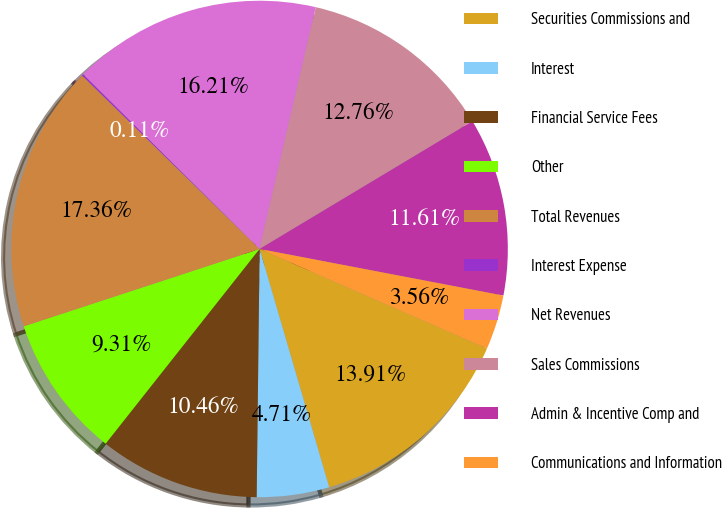Convert chart to OTSL. <chart><loc_0><loc_0><loc_500><loc_500><pie_chart><fcel>Securities Commissions and<fcel>Interest<fcel>Financial Service Fees<fcel>Other<fcel>Total Revenues<fcel>Interest Expense<fcel>Net Revenues<fcel>Sales Commissions<fcel>Admin & Incentive Comp and<fcel>Communications and Information<nl><fcel>13.91%<fcel>4.71%<fcel>10.46%<fcel>9.31%<fcel>17.36%<fcel>0.11%<fcel>16.21%<fcel>12.76%<fcel>11.61%<fcel>3.56%<nl></chart> 